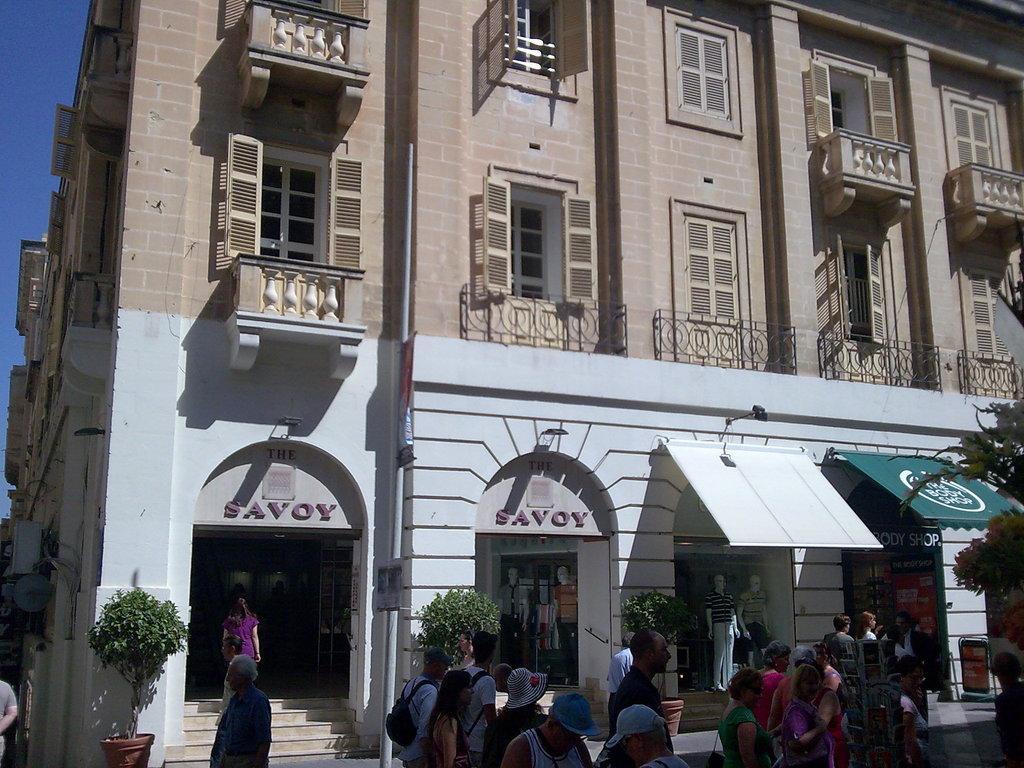Describe this image in one or two sentences. In this image there is a building which contains a few stores in it and there is a text written on the building, in front of it there is a group of people. 